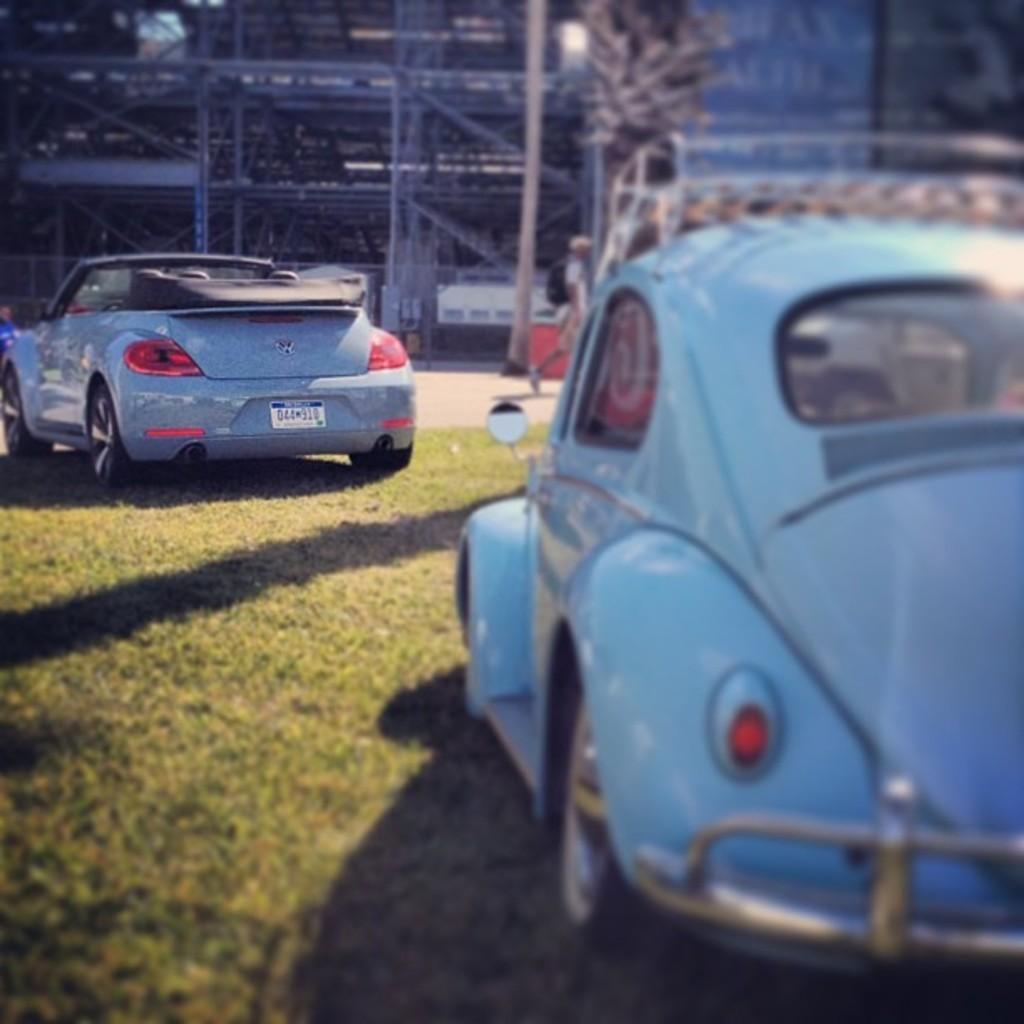How would you summarize this image in a sentence or two? In this image in front there are two cars parked on the surface of the grass. At the center of the image there is a road. In the background of the image there are buildings. 